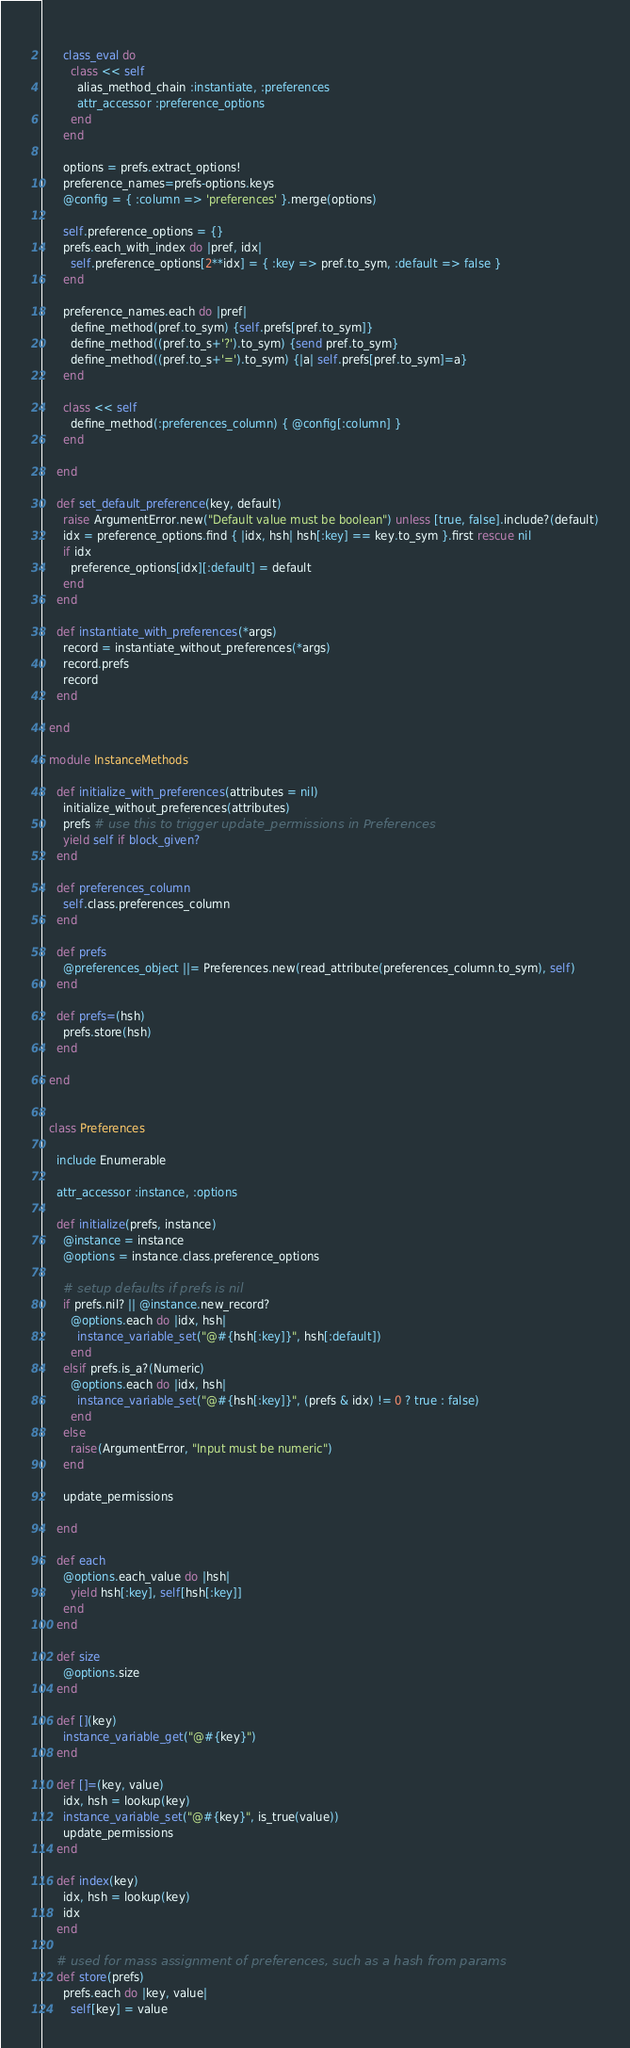Convert code to text. <code><loc_0><loc_0><loc_500><loc_500><_Ruby_>      
      class_eval do
        class << self
          alias_method_chain :instantiate, :preferences
          attr_accessor :preference_options
        end
      end
      
      options = prefs.extract_options!
      preference_names=prefs-options.keys
      @config = { :column => 'preferences' }.merge(options)
      
      self.preference_options = {}
      prefs.each_with_index do |pref, idx|
        self.preference_options[2**idx] = { :key => pref.to_sym, :default => false }
      end
      
      preference_names.each do |pref|        
        define_method(pref.to_sym) {self.prefs[pref.to_sym]}
        define_method((pref.to_s+'?').to_sym) {send pref.to_sym}
        define_method((pref.to_s+'=').to_sym) {|a| self.prefs[pref.to_sym]=a}
      end
      
      class << self
        define_method(:preferences_column) { @config[:column] }
      end
            
    end
    
    def set_default_preference(key, default)
      raise ArgumentError.new("Default value must be boolean") unless [true, false].include?(default)
      idx = preference_options.find { |idx, hsh| hsh[:key] == key.to_sym }.first rescue nil
      if idx
        preference_options[idx][:default] = default
      end
    end
    
    def instantiate_with_preferences(*args)
      record = instantiate_without_preferences(*args)
      record.prefs
      record
    end
    
  end
  
  module InstanceMethods
    
    def initialize_with_preferences(attributes = nil)
      initialize_without_preferences(attributes)
      prefs # use this to trigger update_permissions in Preferences
      yield self if block_given?
    end
    
    def preferences_column
      self.class.preferences_column
    end
    
    def prefs
      @preferences_object ||= Preferences.new(read_attribute(preferences_column.to_sym), self)
    end
    
    def prefs=(hsh)
      prefs.store(hsh)
    end
    
  end
  
  
  class Preferences
    
    include Enumerable
    
    attr_accessor :instance, :options
    
    def initialize(prefs, instance)
      @instance = instance
      @options = instance.class.preference_options
      
      # setup defaults if prefs is nil
      if prefs.nil? || @instance.new_record?
        @options.each do |idx, hsh|
          instance_variable_set("@#{hsh[:key]}", hsh[:default])
        end
      elsif prefs.is_a?(Numeric)
        @options.each do |idx, hsh|
          instance_variable_set("@#{hsh[:key]}", (prefs & idx) != 0 ? true : false)
        end
      else
        raise(ArgumentError, "Input must be numeric")
      end
      
      update_permissions
      
    end
    
    def each
      @options.each_value do |hsh|
        yield hsh[:key], self[hsh[:key]]
      end
    end
    
    def size
      @options.size
    end
    
    def [](key)
      instance_variable_get("@#{key}")
    end
    
    def []=(key, value)
      idx, hsh = lookup(key)
      instance_variable_set("@#{key}", is_true(value))
      update_permissions
    end
    
    def index(key)
      idx, hsh = lookup(key)
      idx
    end
    
    # used for mass assignment of preferences, such as a hash from params
    def store(prefs)
      prefs.each do |key, value|
        self[key] = value</code> 